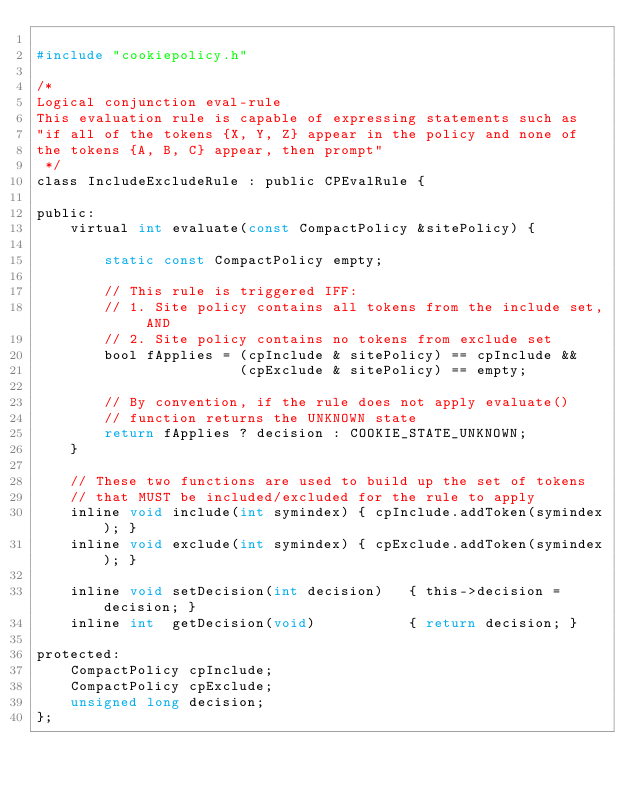<code> <loc_0><loc_0><loc_500><loc_500><_C_>
#include "cookiepolicy.h"

/* 
Logical conjunction eval-rule
This evaluation rule is capable of expressing statements such as
"if all of the tokens {X, Y, Z} appear in the policy and none of
the tokens {A, B, C} appear, then prompt"
 */
class IncludeExcludeRule : public CPEvalRule {

public:
    virtual int evaluate(const CompactPolicy &sitePolicy) {

        static const CompactPolicy empty;

        // This rule is triggered IFF:
        // 1. Site policy contains all tokens from the include set, AND
        // 2. Site policy contains no tokens from exclude set
        bool fApplies = (cpInclude & sitePolicy) == cpInclude &&
                        (cpExclude & sitePolicy) == empty;

        // By convention, if the rule does not apply evaluate()
        // function returns the UNKNOWN state
        return fApplies ? decision : COOKIE_STATE_UNKNOWN;
    }

    // These two functions are used to build up the set of tokens
    // that MUST be included/excluded for the rule to apply
    inline void include(int symindex) { cpInclude.addToken(symindex); }
    inline void exclude(int symindex) { cpExclude.addToken(symindex); }

    inline void setDecision(int decision)   { this->decision = decision; }
    inline int  getDecision(void)           { return decision; }

protected:
    CompactPolicy cpInclude;
    CompactPolicy cpExclude;
    unsigned long decision;
};
</code> 